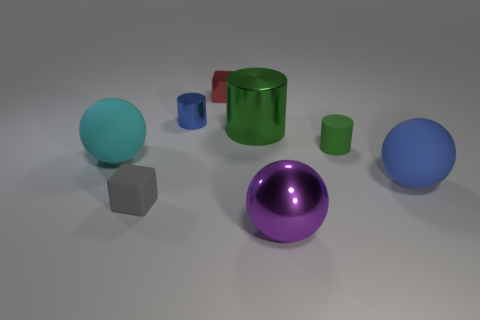Could you describe the lighting and shadows in the scene? The lighting in the scene is soft and diffused, coming from an overhead source, which suggests an indoor setting. Shadows are gently cast to the right of the objects, indicating the light source is to the top-left of the image. This type of lighting creates a calm atmosphere and highlights the shapes of the objects without creating harsh or overly dramatic shadows. 